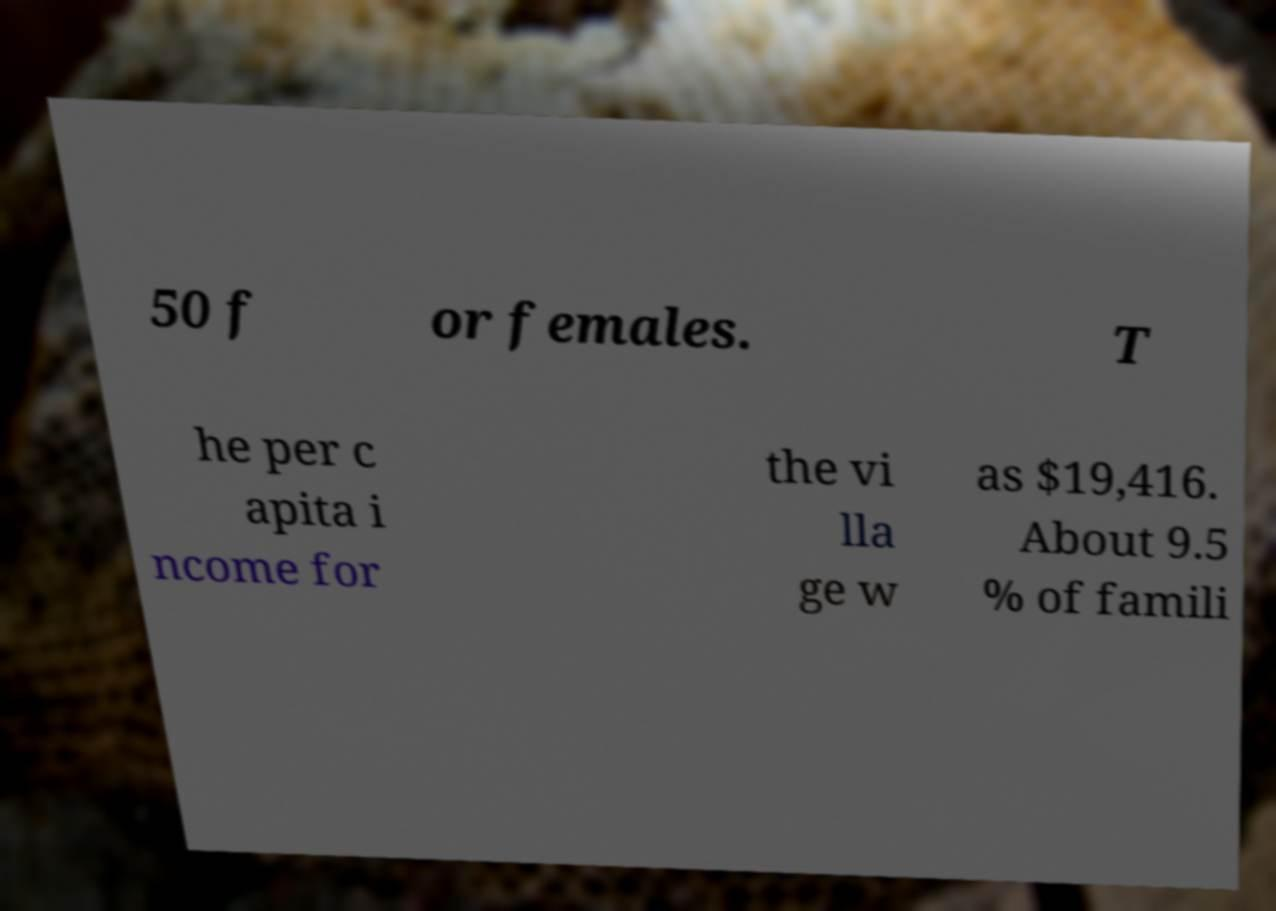Please read and relay the text visible in this image. What does it say? 50 f or females. T he per c apita i ncome for the vi lla ge w as $19,416. About 9.5 % of famili 